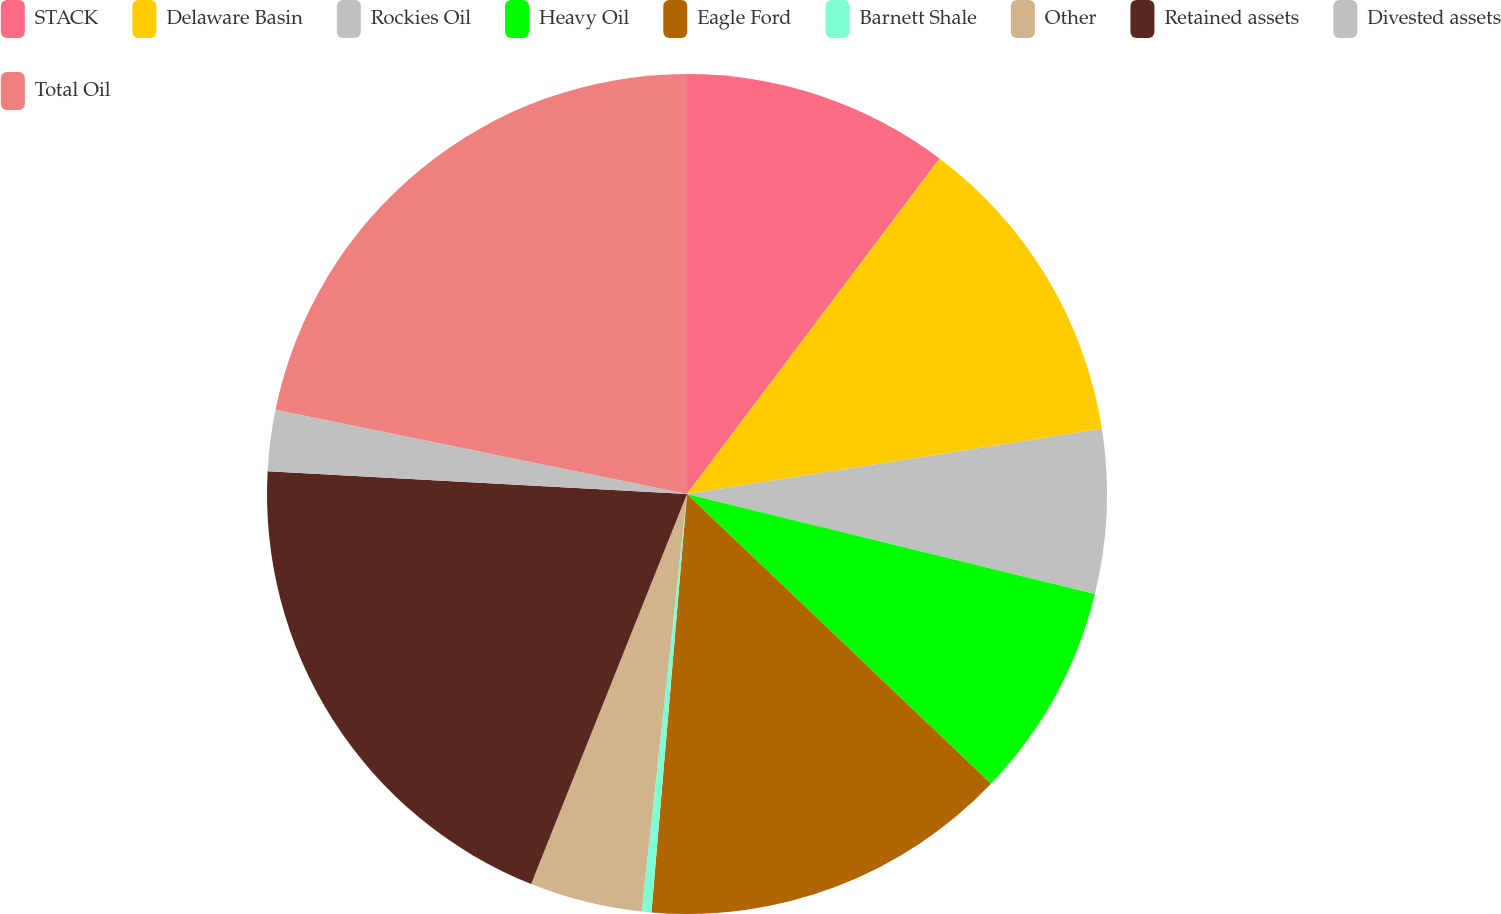Convert chart. <chart><loc_0><loc_0><loc_500><loc_500><pie_chart><fcel>STACK<fcel>Delaware Basin<fcel>Rockies Oil<fcel>Heavy Oil<fcel>Eagle Ford<fcel>Barnett Shale<fcel>Other<fcel>Retained assets<fcel>Divested assets<fcel>Total Oil<nl><fcel>10.27%<fcel>12.25%<fcel>6.31%<fcel>8.29%<fcel>14.23%<fcel>0.37%<fcel>4.33%<fcel>19.81%<fcel>2.35%<fcel>21.79%<nl></chart> 